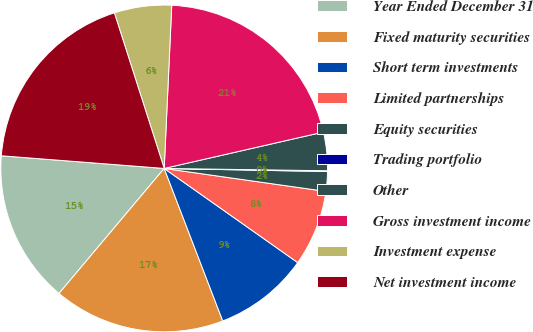Convert chart to OTSL. <chart><loc_0><loc_0><loc_500><loc_500><pie_chart><fcel>Year Ended December 31<fcel>Fixed maturity securities<fcel>Short term investments<fcel>Limited partnerships<fcel>Equity securities<fcel>Trading portfolio<fcel>Other<fcel>Gross investment income<fcel>Investment expense<fcel>Net investment income<nl><fcel>15.1%<fcel>16.97%<fcel>9.39%<fcel>7.53%<fcel>1.94%<fcel>0.08%<fcel>3.8%<fcel>20.69%<fcel>5.67%<fcel>18.83%<nl></chart> 